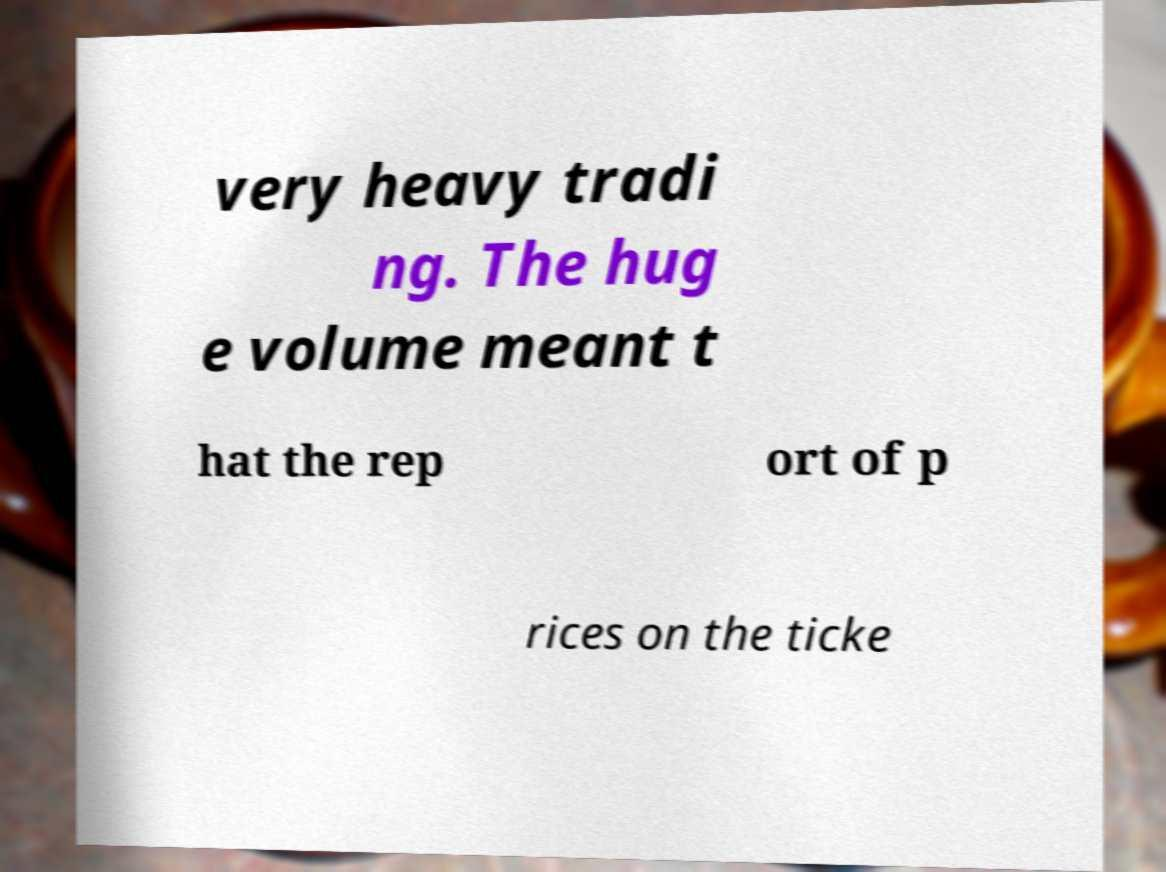Can you read and provide the text displayed in the image?This photo seems to have some interesting text. Can you extract and type it out for me? very heavy tradi ng. The hug e volume meant t hat the rep ort of p rices on the ticke 